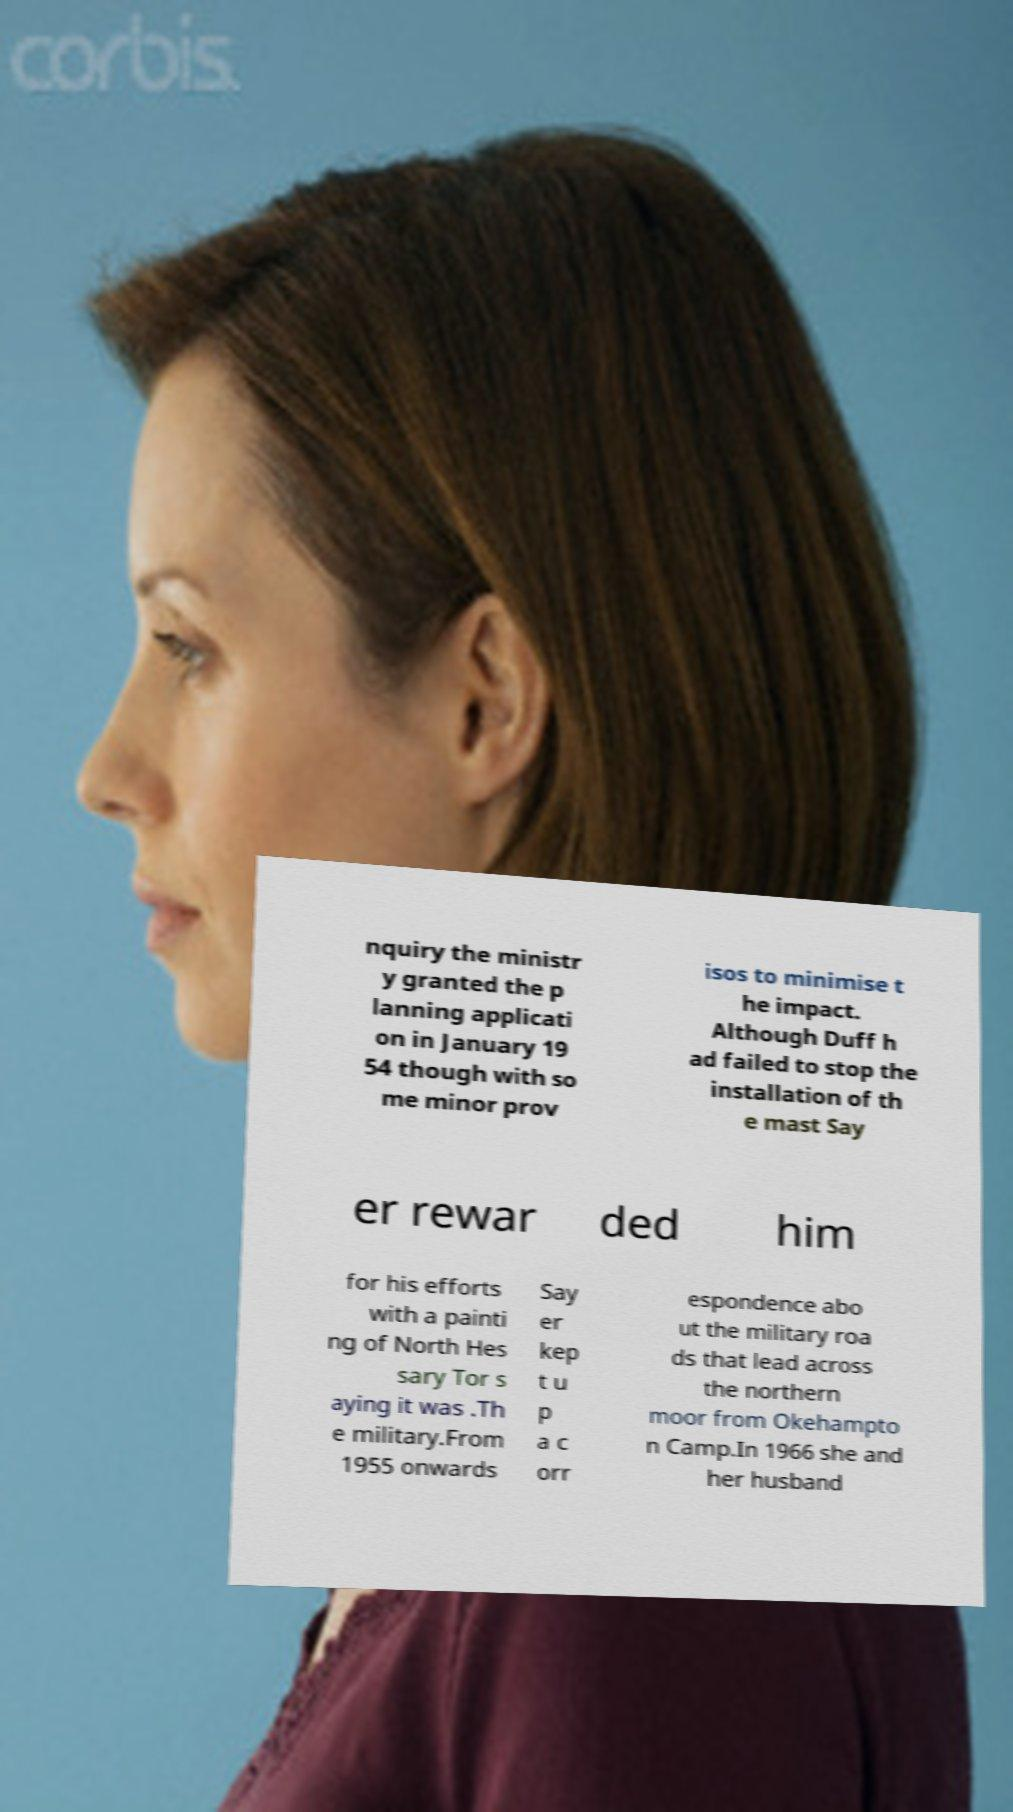Could you extract and type out the text from this image? nquiry the ministr y granted the p lanning applicati on in January 19 54 though with so me minor prov isos to minimise t he impact. Although Duff h ad failed to stop the installation of th e mast Say er rewar ded him for his efforts with a painti ng of North Hes sary Tor s aying it was .Th e military.From 1955 onwards Say er kep t u p a c orr espondence abo ut the military roa ds that lead across the northern moor from Okehampto n Camp.In 1966 she and her husband 